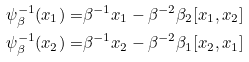<formula> <loc_0><loc_0><loc_500><loc_500>\psi _ { \beta } ^ { - 1 } ( x _ { 1 } ) = & \beta ^ { - 1 } x _ { 1 } - \beta ^ { - 2 } \beta _ { 2 } [ x _ { 1 } , x _ { 2 } ] \\ \psi _ { \beta } ^ { - 1 } ( x _ { 2 } ) = & \beta ^ { - 1 } x _ { 2 } - \beta ^ { - 2 } \beta _ { 1 } [ x _ { 2 } , x _ { 1 } ]</formula> 